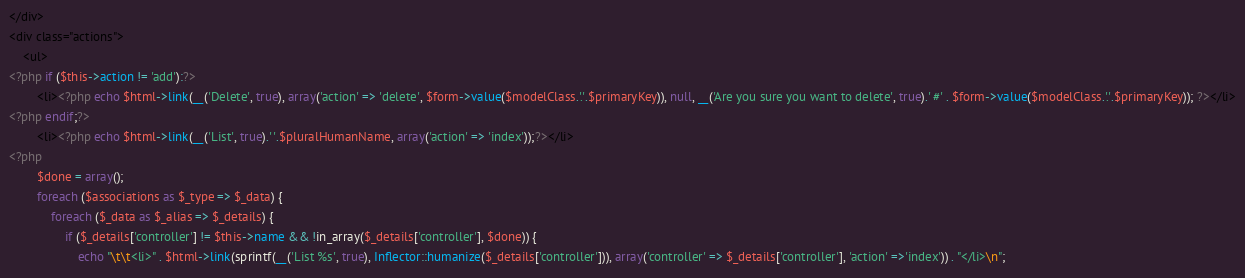<code> <loc_0><loc_0><loc_500><loc_500><_PHP_></div>
<div class="actions">
	<ul>
<?php if ($this->action != 'add'):?>
		<li><?php echo $html->link(__('Delete', true), array('action' => 'delete', $form->value($modelClass.'.'.$primaryKey)), null, __('Are you sure you want to delete', true).' #' . $form->value($modelClass.'.'.$primaryKey)); ?></li>
<?php endif;?>
		<li><?php echo $html->link(__('List', true).' '.$pluralHumanName, array('action' => 'index'));?></li>
<?php
		$done = array();
		foreach ($associations as $_type => $_data) {
			foreach ($_data as $_alias => $_details) {
				if ($_details['controller'] != $this->name && !in_array($_details['controller'], $done)) {
					echo "\t\t<li>" . $html->link(sprintf(__('List %s', true), Inflector::humanize($_details['controller'])), array('controller' => $_details['controller'], 'action' =>'index')) . "</li>\n";</code> 